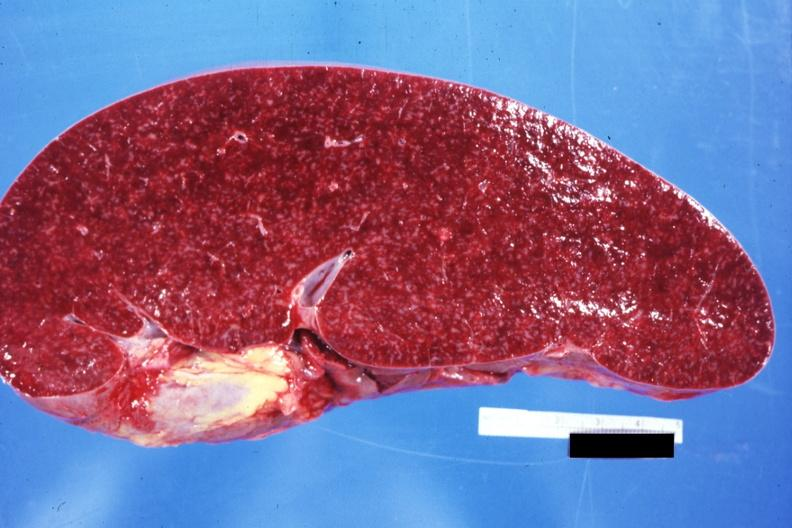does stillborn macerated appear normal see other sides this case?
Answer the question using a single word or phrase. No 